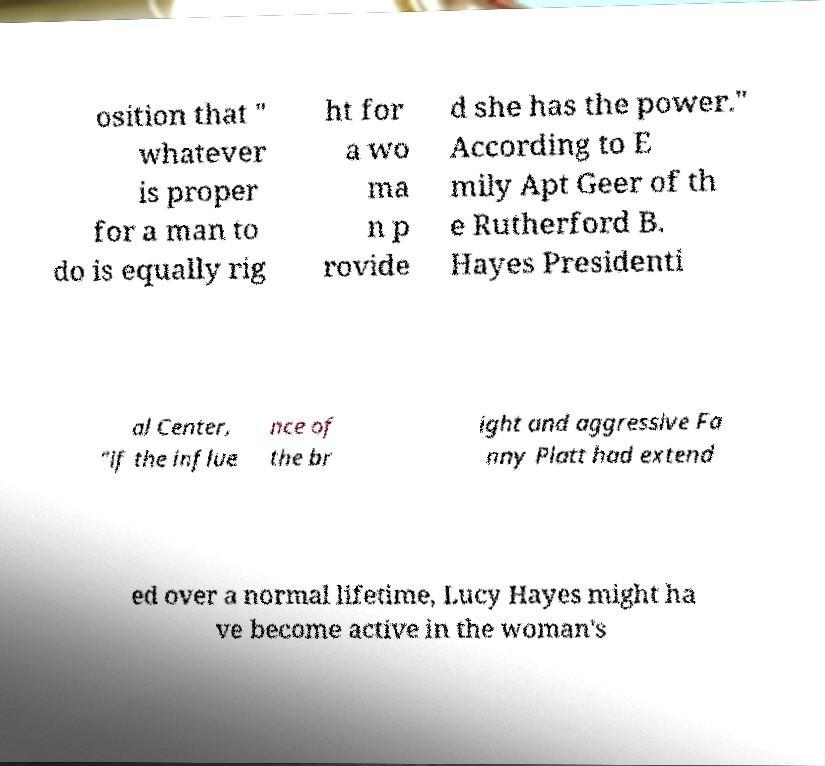There's text embedded in this image that I need extracted. Can you transcribe it verbatim? osition that " whatever is proper for a man to do is equally rig ht for a wo ma n p rovide d she has the power." According to E mily Apt Geer of th e Rutherford B. Hayes Presidenti al Center, "if the influe nce of the br ight and aggressive Fa nny Platt had extend ed over a normal lifetime, Lucy Hayes might ha ve become active in the woman's 